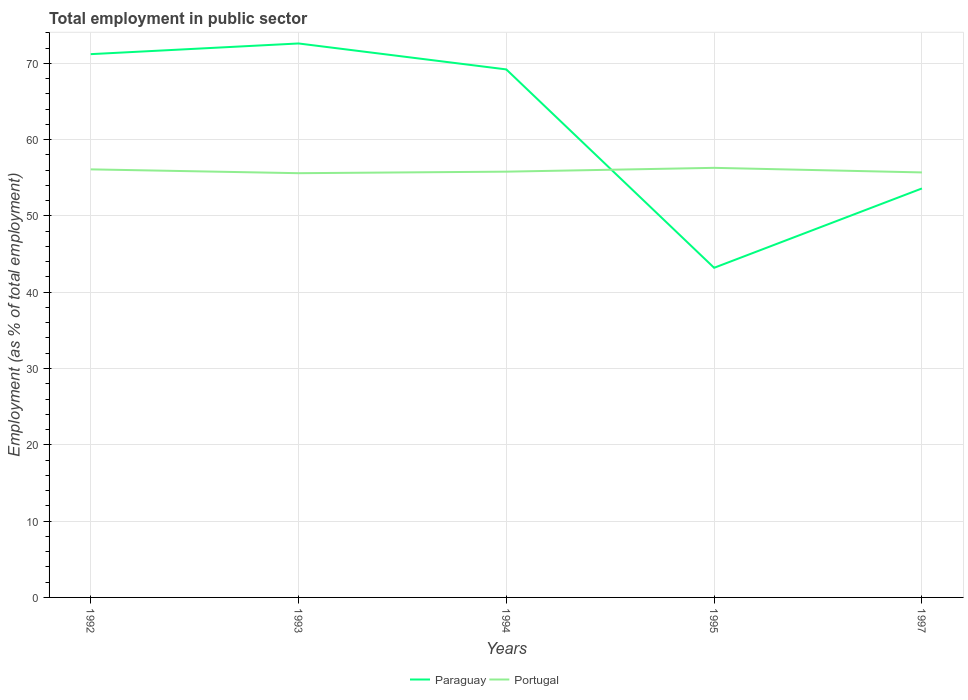How many different coloured lines are there?
Offer a terse response. 2. Does the line corresponding to Paraguay intersect with the line corresponding to Portugal?
Make the answer very short. Yes. Is the number of lines equal to the number of legend labels?
Make the answer very short. Yes. Across all years, what is the maximum employment in public sector in Portugal?
Provide a succinct answer. 55.6. In which year was the employment in public sector in Portugal maximum?
Provide a short and direct response. 1993. What is the total employment in public sector in Paraguay in the graph?
Ensure brevity in your answer.  15.6. What is the difference between the highest and the second highest employment in public sector in Paraguay?
Offer a terse response. 29.4. What is the difference between the highest and the lowest employment in public sector in Paraguay?
Offer a very short reply. 3. How many lines are there?
Offer a very short reply. 2. What is the difference between two consecutive major ticks on the Y-axis?
Give a very brief answer. 10. How many legend labels are there?
Provide a short and direct response. 2. What is the title of the graph?
Your answer should be compact. Total employment in public sector. What is the label or title of the X-axis?
Keep it short and to the point. Years. What is the label or title of the Y-axis?
Your answer should be very brief. Employment (as % of total employment). What is the Employment (as % of total employment) of Paraguay in 1992?
Your answer should be very brief. 71.2. What is the Employment (as % of total employment) in Portugal in 1992?
Keep it short and to the point. 56.1. What is the Employment (as % of total employment) of Paraguay in 1993?
Provide a short and direct response. 72.6. What is the Employment (as % of total employment) of Portugal in 1993?
Keep it short and to the point. 55.6. What is the Employment (as % of total employment) in Paraguay in 1994?
Provide a succinct answer. 69.2. What is the Employment (as % of total employment) of Portugal in 1994?
Your answer should be compact. 55.8. What is the Employment (as % of total employment) in Paraguay in 1995?
Keep it short and to the point. 43.2. What is the Employment (as % of total employment) in Portugal in 1995?
Keep it short and to the point. 56.3. What is the Employment (as % of total employment) in Paraguay in 1997?
Ensure brevity in your answer.  53.6. What is the Employment (as % of total employment) in Portugal in 1997?
Provide a succinct answer. 55.7. Across all years, what is the maximum Employment (as % of total employment) in Paraguay?
Offer a very short reply. 72.6. Across all years, what is the maximum Employment (as % of total employment) in Portugal?
Your response must be concise. 56.3. Across all years, what is the minimum Employment (as % of total employment) of Paraguay?
Your response must be concise. 43.2. Across all years, what is the minimum Employment (as % of total employment) in Portugal?
Offer a very short reply. 55.6. What is the total Employment (as % of total employment) of Paraguay in the graph?
Provide a short and direct response. 309.8. What is the total Employment (as % of total employment) in Portugal in the graph?
Your response must be concise. 279.5. What is the difference between the Employment (as % of total employment) in Paraguay in 1992 and that in 1993?
Your answer should be compact. -1.4. What is the difference between the Employment (as % of total employment) in Portugal in 1992 and that in 1994?
Offer a very short reply. 0.3. What is the difference between the Employment (as % of total employment) in Paraguay in 1992 and that in 1997?
Your answer should be compact. 17.6. What is the difference between the Employment (as % of total employment) of Paraguay in 1993 and that in 1994?
Keep it short and to the point. 3.4. What is the difference between the Employment (as % of total employment) in Portugal in 1993 and that in 1994?
Provide a short and direct response. -0.2. What is the difference between the Employment (as % of total employment) in Paraguay in 1993 and that in 1995?
Offer a terse response. 29.4. What is the difference between the Employment (as % of total employment) of Portugal in 1993 and that in 1995?
Provide a succinct answer. -0.7. What is the difference between the Employment (as % of total employment) of Paraguay in 1993 and that in 1997?
Keep it short and to the point. 19. What is the difference between the Employment (as % of total employment) of Portugal in 1993 and that in 1997?
Keep it short and to the point. -0.1. What is the difference between the Employment (as % of total employment) in Portugal in 1994 and that in 1995?
Provide a succinct answer. -0.5. What is the difference between the Employment (as % of total employment) of Paraguay in 1994 and that in 1997?
Provide a short and direct response. 15.6. What is the difference between the Employment (as % of total employment) in Paraguay in 1995 and that in 1997?
Provide a short and direct response. -10.4. What is the difference between the Employment (as % of total employment) of Portugal in 1995 and that in 1997?
Offer a very short reply. 0.6. What is the difference between the Employment (as % of total employment) in Paraguay in 1993 and the Employment (as % of total employment) in Portugal in 1995?
Your answer should be very brief. 16.3. What is the difference between the Employment (as % of total employment) of Paraguay in 1994 and the Employment (as % of total employment) of Portugal in 1997?
Give a very brief answer. 13.5. What is the difference between the Employment (as % of total employment) in Paraguay in 1995 and the Employment (as % of total employment) in Portugal in 1997?
Your response must be concise. -12.5. What is the average Employment (as % of total employment) in Paraguay per year?
Offer a very short reply. 61.96. What is the average Employment (as % of total employment) of Portugal per year?
Your response must be concise. 55.9. In the year 1993, what is the difference between the Employment (as % of total employment) of Paraguay and Employment (as % of total employment) of Portugal?
Your answer should be compact. 17. In the year 1994, what is the difference between the Employment (as % of total employment) in Paraguay and Employment (as % of total employment) in Portugal?
Provide a short and direct response. 13.4. In the year 1995, what is the difference between the Employment (as % of total employment) of Paraguay and Employment (as % of total employment) of Portugal?
Your answer should be very brief. -13.1. What is the ratio of the Employment (as % of total employment) of Paraguay in 1992 to that in 1993?
Offer a very short reply. 0.98. What is the ratio of the Employment (as % of total employment) of Paraguay in 1992 to that in 1994?
Provide a succinct answer. 1.03. What is the ratio of the Employment (as % of total employment) of Portugal in 1992 to that in 1994?
Your answer should be very brief. 1.01. What is the ratio of the Employment (as % of total employment) in Paraguay in 1992 to that in 1995?
Make the answer very short. 1.65. What is the ratio of the Employment (as % of total employment) of Portugal in 1992 to that in 1995?
Give a very brief answer. 1. What is the ratio of the Employment (as % of total employment) in Paraguay in 1992 to that in 1997?
Your response must be concise. 1.33. What is the ratio of the Employment (as % of total employment) in Paraguay in 1993 to that in 1994?
Give a very brief answer. 1.05. What is the ratio of the Employment (as % of total employment) in Paraguay in 1993 to that in 1995?
Provide a succinct answer. 1.68. What is the ratio of the Employment (as % of total employment) of Portugal in 1993 to that in 1995?
Offer a very short reply. 0.99. What is the ratio of the Employment (as % of total employment) of Paraguay in 1993 to that in 1997?
Ensure brevity in your answer.  1.35. What is the ratio of the Employment (as % of total employment) in Portugal in 1993 to that in 1997?
Provide a short and direct response. 1. What is the ratio of the Employment (as % of total employment) in Paraguay in 1994 to that in 1995?
Keep it short and to the point. 1.6. What is the ratio of the Employment (as % of total employment) of Portugal in 1994 to that in 1995?
Offer a terse response. 0.99. What is the ratio of the Employment (as % of total employment) of Paraguay in 1994 to that in 1997?
Your answer should be very brief. 1.29. What is the ratio of the Employment (as % of total employment) in Paraguay in 1995 to that in 1997?
Ensure brevity in your answer.  0.81. What is the ratio of the Employment (as % of total employment) in Portugal in 1995 to that in 1997?
Your answer should be compact. 1.01. What is the difference between the highest and the second highest Employment (as % of total employment) of Paraguay?
Provide a short and direct response. 1.4. What is the difference between the highest and the second highest Employment (as % of total employment) of Portugal?
Offer a terse response. 0.2. What is the difference between the highest and the lowest Employment (as % of total employment) of Paraguay?
Keep it short and to the point. 29.4. 